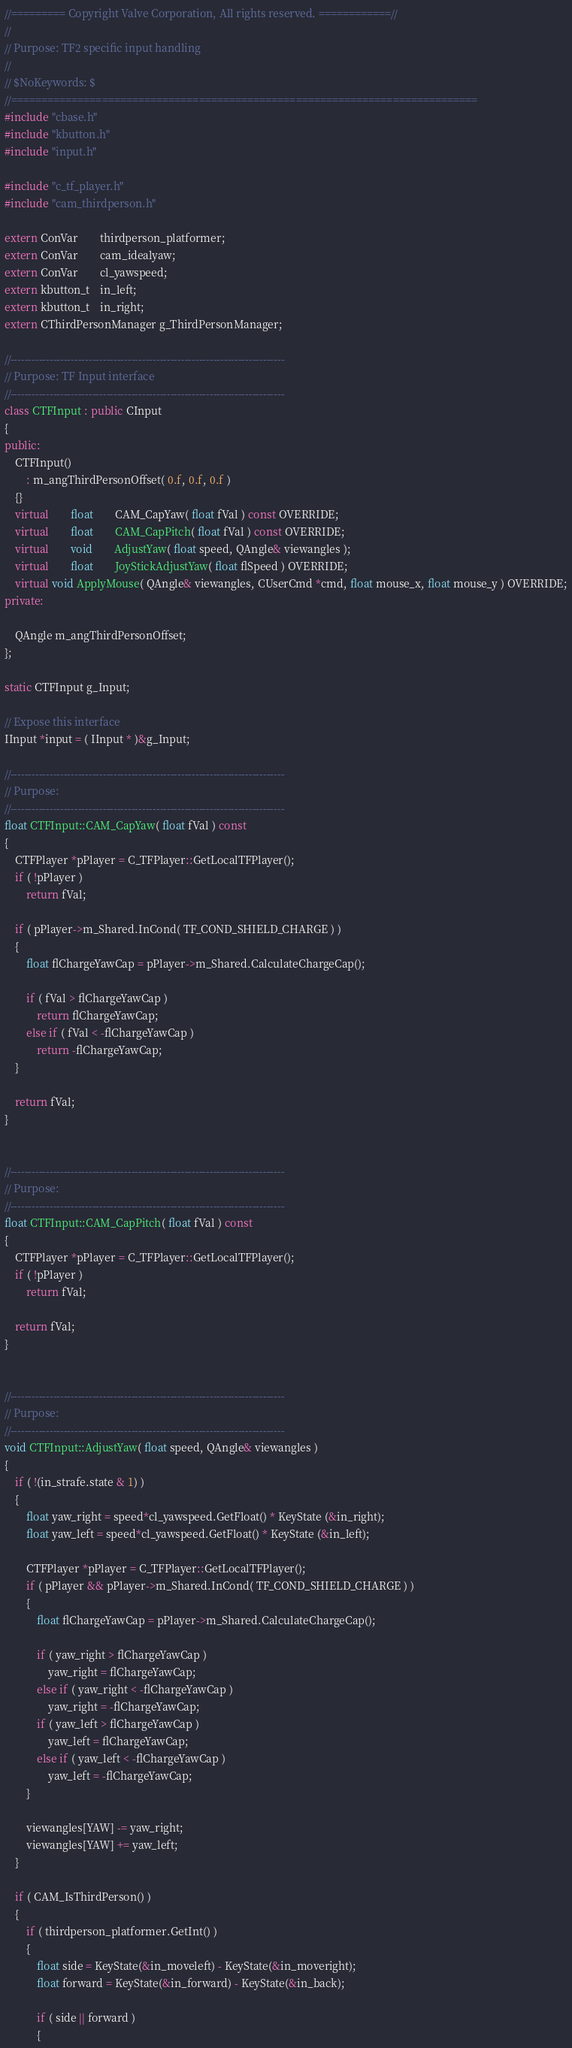Convert code to text. <code><loc_0><loc_0><loc_500><loc_500><_C++_>//========= Copyright Valve Corporation, All rights reserved. ============//
//
// Purpose: TF2 specific input handling
//
// $NoKeywords: $
//=============================================================================
#include "cbase.h"
#include "kbutton.h"
#include "input.h"

#include "c_tf_player.h"
#include "cam_thirdperson.h"

extern ConVar		thirdperson_platformer;
extern ConVar		cam_idealyaw;
extern ConVar		cl_yawspeed;
extern kbutton_t	in_left;
extern kbutton_t	in_right;
extern CThirdPersonManager g_ThirdPersonManager;

//-----------------------------------------------------------------------------
// Purpose: TF Input interface
//-----------------------------------------------------------------------------
class CTFInput : public CInput
{
public:
	CTFInput()
		: m_angThirdPersonOffset( 0.f, 0.f, 0.f )
	{}
	virtual		float		CAM_CapYaw( float fVal ) const OVERRIDE;
	virtual		float		CAM_CapPitch( float fVal ) const OVERRIDE;
	virtual		void		AdjustYaw( float speed, QAngle& viewangles );
	virtual		float		JoyStickAdjustYaw( float flSpeed ) OVERRIDE;
	virtual void ApplyMouse( QAngle& viewangles, CUserCmd *cmd, float mouse_x, float mouse_y ) OVERRIDE;
private:

	QAngle m_angThirdPersonOffset;
};

static CTFInput g_Input;

// Expose this interface
IInput *input = ( IInput * )&g_Input;

//-----------------------------------------------------------------------------
// Purpose: 
//-----------------------------------------------------------------------------
float CTFInput::CAM_CapYaw( float fVal ) const
{
	CTFPlayer *pPlayer = C_TFPlayer::GetLocalTFPlayer();
	if ( !pPlayer )
		return fVal;

	if ( pPlayer->m_Shared.InCond( TF_COND_SHIELD_CHARGE ) )
	{
		float flChargeYawCap = pPlayer->m_Shared.CalculateChargeCap();

		if ( fVal > flChargeYawCap )
			return flChargeYawCap;
		else if ( fVal < -flChargeYawCap )
			return -flChargeYawCap;
	}

	return fVal;
}


//-----------------------------------------------------------------------------
// Purpose: 
//-----------------------------------------------------------------------------
float CTFInput::CAM_CapPitch( float fVal ) const
{
	CTFPlayer *pPlayer = C_TFPlayer::GetLocalTFPlayer();
	if ( !pPlayer )
		return fVal;

	return fVal;
}


//-----------------------------------------------------------------------------
// Purpose: 
//-----------------------------------------------------------------------------
void CTFInput::AdjustYaw( float speed, QAngle& viewangles )
{
	if ( !(in_strafe.state & 1) )
	{
		float yaw_right = speed*cl_yawspeed.GetFloat() * KeyState (&in_right);
		float yaw_left = speed*cl_yawspeed.GetFloat() * KeyState (&in_left);

		CTFPlayer *pPlayer = C_TFPlayer::GetLocalTFPlayer();
		if ( pPlayer && pPlayer->m_Shared.InCond( TF_COND_SHIELD_CHARGE ) )
		{
			float flChargeYawCap = pPlayer->m_Shared.CalculateChargeCap();

			if ( yaw_right > flChargeYawCap )
				yaw_right = flChargeYawCap;
			else if ( yaw_right < -flChargeYawCap )
				yaw_right = -flChargeYawCap;
			if ( yaw_left > flChargeYawCap )
				yaw_left = flChargeYawCap;
			else if ( yaw_left < -flChargeYawCap )
				yaw_left = -flChargeYawCap;
		}

		viewangles[YAW] -= yaw_right;
		viewangles[YAW] += yaw_left;
	}

	if ( CAM_IsThirdPerson() )
	{
		if ( thirdperson_platformer.GetInt() )
		{
			float side = KeyState(&in_moveleft) - KeyState(&in_moveright);
			float forward = KeyState(&in_forward) - KeyState(&in_back);

			if ( side || forward )
			{</code> 